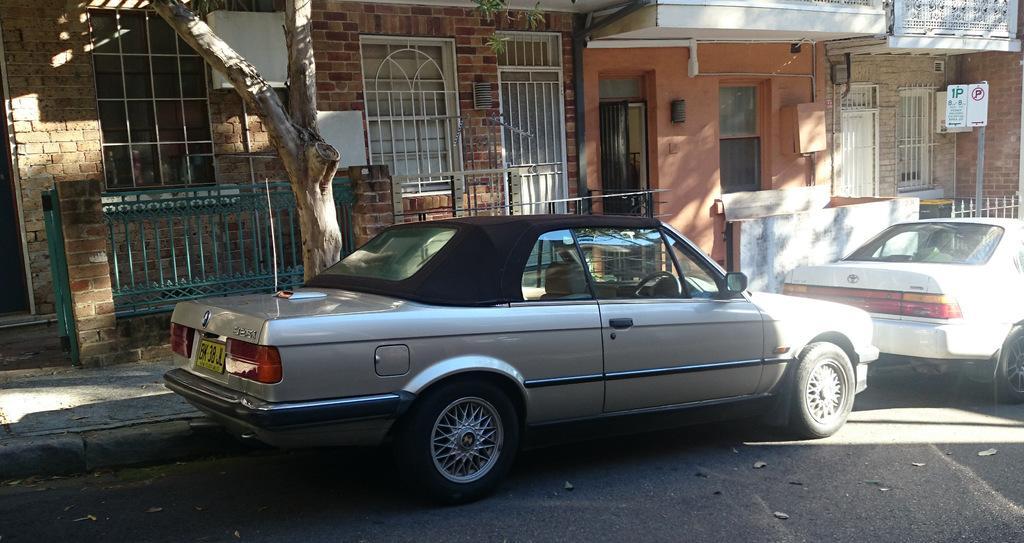In one or two sentences, can you explain what this image depicts? In this image I can see few vehicles. In front the vehicle is in black and silver color, background I can see a building in brown and cream color and I can also see few windows and the railing. 